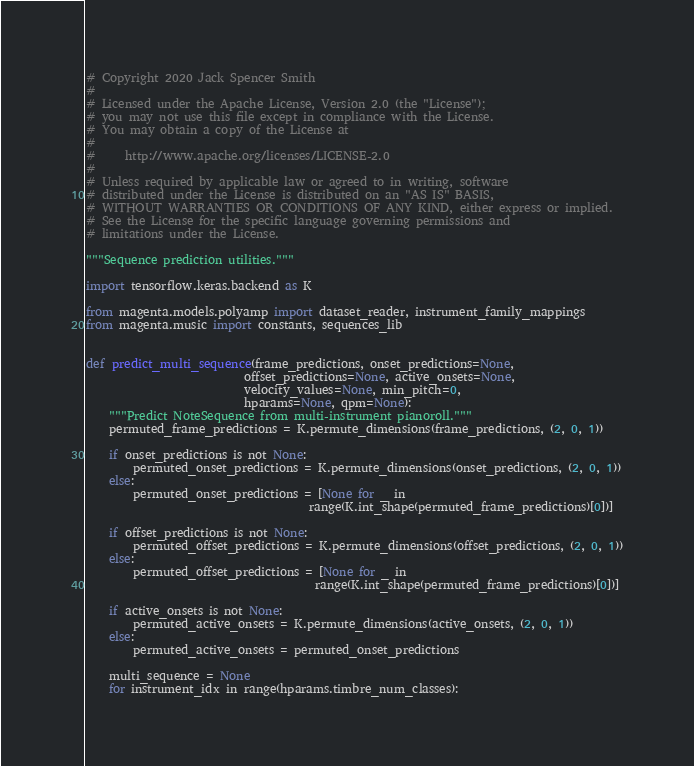<code> <loc_0><loc_0><loc_500><loc_500><_Python_># Copyright 2020 Jack Spencer Smith
#
# Licensed under the Apache License, Version 2.0 (the "License");
# you may not use this file except in compliance with the License.
# You may obtain a copy of the License at
#
#     http://www.apache.org/licenses/LICENSE-2.0
#
# Unless required by applicable law or agreed to in writing, software
# distributed under the License is distributed on an "AS IS" BASIS,
# WITHOUT WARRANTIES OR CONDITIONS OF ANY KIND, either express or implied.
# See the License for the specific language governing permissions and
# limitations under the License.

"""Sequence prediction utilities."""

import tensorflow.keras.backend as K

from magenta.models.polyamp import dataset_reader, instrument_family_mappings
from magenta.music import constants, sequences_lib


def predict_multi_sequence(frame_predictions, onset_predictions=None,
                           offset_predictions=None, active_onsets=None,
                           velocity_values=None, min_pitch=0,
                           hparams=None, qpm=None):
    """Predict NoteSequence from multi-instrument pianoroll."""
    permuted_frame_predictions = K.permute_dimensions(frame_predictions, (2, 0, 1))

    if onset_predictions is not None:
        permuted_onset_predictions = K.permute_dimensions(onset_predictions, (2, 0, 1))
    else:
        permuted_onset_predictions = [None for _ in
                                      range(K.int_shape(permuted_frame_predictions)[0])]

    if offset_predictions is not None:
        permuted_offset_predictions = K.permute_dimensions(offset_predictions, (2, 0, 1))
    else:
        permuted_offset_predictions = [None for _ in
                                       range(K.int_shape(permuted_frame_predictions)[0])]

    if active_onsets is not None:
        permuted_active_onsets = K.permute_dimensions(active_onsets, (2, 0, 1))
    else:
        permuted_active_onsets = permuted_onset_predictions

    multi_sequence = None
    for instrument_idx in range(hparams.timbre_num_classes):</code> 